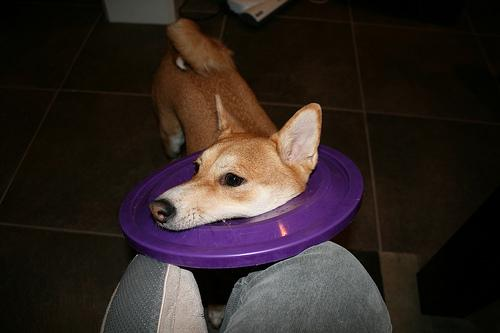In a short sentence, describe the primary object surrounding the dog's head. A purple frisbee with a central hole is around the dog's head. Write a concise description of the dog's interaction with an object. The dog has its head through a purple frisbee with an inner hole. Describe the color and appearance of the dog and an object it is interacting with. A blond dog with pointy ears has a purple frisbee with a hole around its head. Mention the most prominent feature of the image and the color of the object. The dog's head is inside a purple frisbee with an opening in the center. Provide a brief description of the main focus in the image. A tan-colored dog with pointy ears has its head through a purple frisbee with a hole in the center. What is the main subject in the image and how is it positioned? A tan dog has its head stuck in a purple frisbee with a center hole. Mention the main action the dog is involved in and an accessory it is interacting with. The dog is sticking its head through a round purple frisbee with a hole in the middle. In one sentence, describe the primary subject and an accessory in the image. A brown dog with pointy ears has a purple frisbee with a hole around its head. What is the most noticeable feature of the dog in the image? The dog's head sticking through a purple frisbee with an inner hole. What is the dog doing with the frisbee in brief? The dog is wearing a purple frisbee with a hole around its head. 